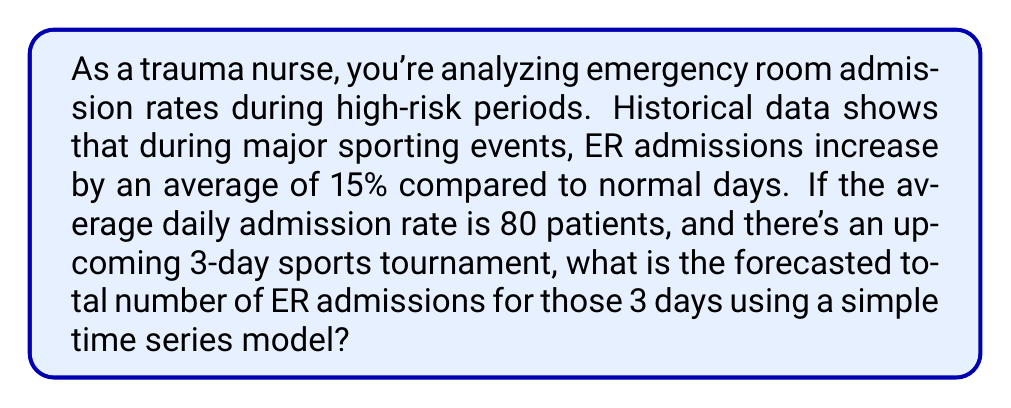What is the answer to this math problem? To solve this problem, we'll use a simple time series forecasting model based on historical data and the given information. Let's break it down step-by-step:

1. Calculate the normal daily admission rate:
   $$ \text{Normal daily rate} = 80 \text{ patients} $$

2. Calculate the increased admission rate during high-risk periods:
   $$ \text{Increase} = 15\% = 0.15 $$
   $$ \text{High-risk daily rate} = \text{Normal daily rate} \times (1 + \text{Increase}) $$
   $$ \text{High-risk daily rate} = 80 \times (1 + 0.15) = 80 \times 1.15 = 92 \text{ patients} $$

3. Calculate the total forecasted admissions for the 3-day tournament:
   $$ \text{Total forecasted admissions} = \text{High-risk daily rate} \times \text{Number of days} $$
   $$ \text{Total forecasted admissions} = 92 \times 3 = 276 \text{ patients} $$

This simple time series model assumes that the increase in admissions is consistent across all three days of the tournament and doesn't account for potential variations between different days or times during the event.
Answer: The forecasted total number of ER admissions for the 3-day sports tournament is 276 patients. 